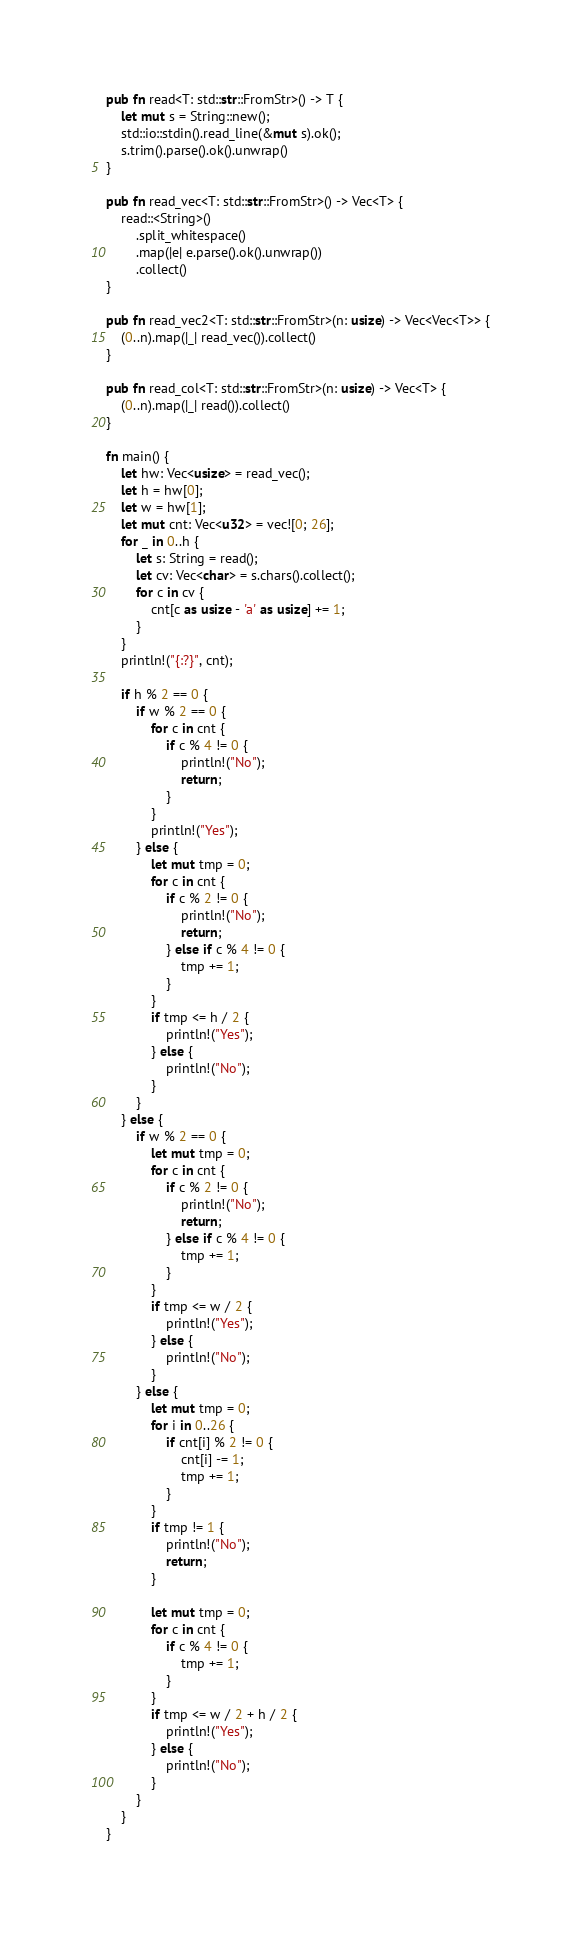Convert code to text. <code><loc_0><loc_0><loc_500><loc_500><_Rust_>pub fn read<T: std::str::FromStr>() -> T {
    let mut s = String::new();
    std::io::stdin().read_line(&mut s).ok();
    s.trim().parse().ok().unwrap()
}

pub fn read_vec<T: std::str::FromStr>() -> Vec<T> {
    read::<String>()
        .split_whitespace()
        .map(|e| e.parse().ok().unwrap())
        .collect()
}

pub fn read_vec2<T: std::str::FromStr>(n: usize) -> Vec<Vec<T>> {
    (0..n).map(|_| read_vec()).collect()
}

pub fn read_col<T: std::str::FromStr>(n: usize) -> Vec<T> {
    (0..n).map(|_| read()).collect()
}

fn main() {
    let hw: Vec<usize> = read_vec();
    let h = hw[0];
    let w = hw[1];
    let mut cnt: Vec<u32> = vec![0; 26];
    for _ in 0..h {
        let s: String = read();
        let cv: Vec<char> = s.chars().collect();
        for c in cv {
            cnt[c as usize - 'a' as usize] += 1;
        }
    }
    println!("{:?}", cnt);

    if h % 2 == 0 {
        if w % 2 == 0 {
            for c in cnt {
                if c % 4 != 0 {
                    println!("No");
                    return;
                }
            }
            println!("Yes");
        } else {
            let mut tmp = 0;
            for c in cnt {
                if c % 2 != 0 {
                    println!("No");
                    return;
                } else if c % 4 != 0 {
                    tmp += 1;
                }
            }
            if tmp <= h / 2 {
                println!("Yes");
            } else {
                println!("No");
            }
        }
    } else {
        if w % 2 == 0 {
            let mut tmp = 0;
            for c in cnt {
                if c % 2 != 0 {
                    println!("No");
                    return;
                } else if c % 4 != 0 {
                    tmp += 1;
                }
            }
            if tmp <= w / 2 {
                println!("Yes");
            } else {
                println!("No");
            }
        } else {
            let mut tmp = 0;
            for i in 0..26 {
                if cnt[i] % 2 != 0 {
                    cnt[i] -= 1;
                    tmp += 1;
                }
            }
            if tmp != 1 {
                println!("No");
                return;
            }

            let mut tmp = 0;
            for c in cnt {
                if c % 4 != 0 {
                    tmp += 1;
                }
            }
            if tmp <= w / 2 + h / 2 {
                println!("Yes");
            } else {
                println!("No");
            }
        }
    }
}
</code> 